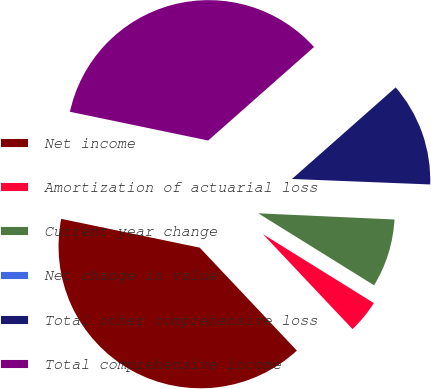<chart> <loc_0><loc_0><loc_500><loc_500><pie_chart><fcel>Net income<fcel>Amortization of actuarial loss<fcel>Current year change<fcel>Net change in value<fcel>Total other comprehensive loss<fcel>Total comprehensive income<nl><fcel>40.3%<fcel>4.11%<fcel>8.13%<fcel>0.09%<fcel>12.15%<fcel>35.22%<nl></chart> 